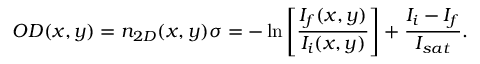<formula> <loc_0><loc_0><loc_500><loc_500>O D ( x , y ) = n _ { 2 D } ( x , y ) \sigma = - \ln \left [ { \frac { I _ { f } ( x , y ) } { I _ { i } ( x , y ) } } \right ] + \frac { I _ { i } - I _ { f } } { I _ { s a t } } .</formula> 